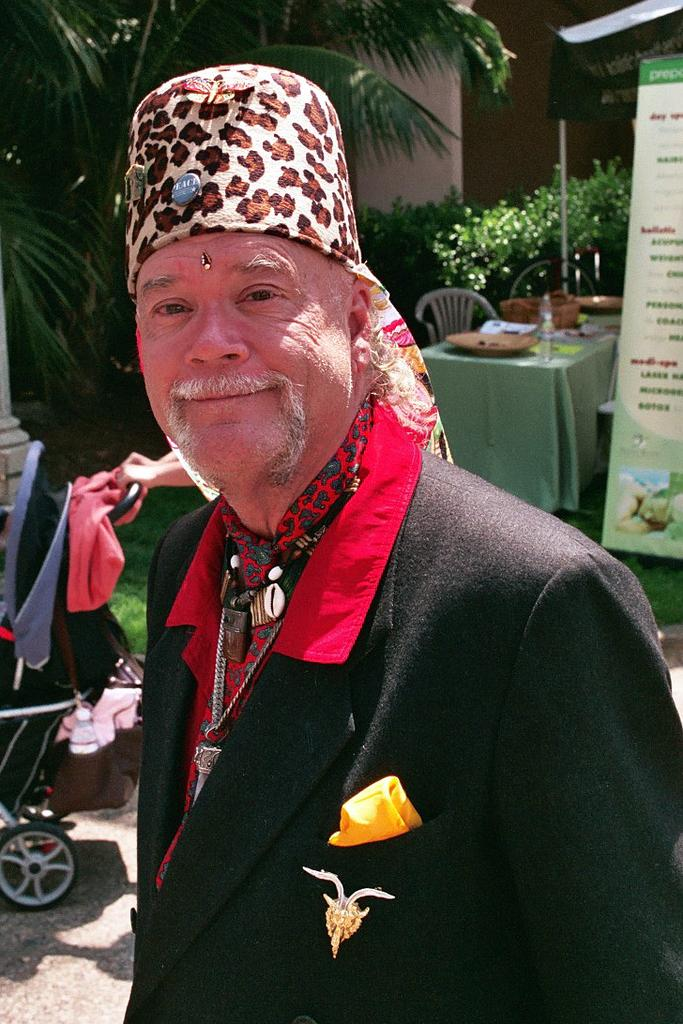Who is the main subject in the foreground of the image? There is a man in the foreground of the image. What object is visible behind the man? There is a trolley behind the man. What furniture can be seen in the image? There is a table and a chair in the image. What is the purpose of the board in the image? The board in the image might be used for displaying information or as a surface for writing or drawing. What type of vegetation is on the left side of the image? There are trees and plants on the left side of the image. What type of yam is being served on the table in the image? There is no yam present in the image; the table does not have any food items on it. Can you see any chickens in the image? There are no chickens visible in the image. Is there a rifle in the image? There is no rifle present in the image. 